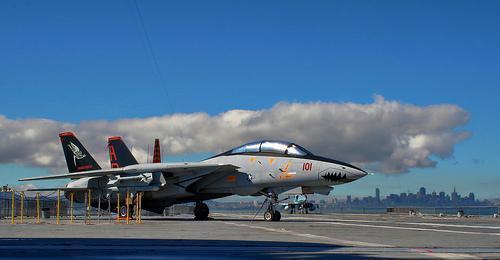How many jets are in the picture?
Give a very brief answer. 1. How many wheels are visible on the plane?
Give a very brief answer. 2. How many blue tails are visible on the rear of the plane?
Give a very brief answer. 2. 